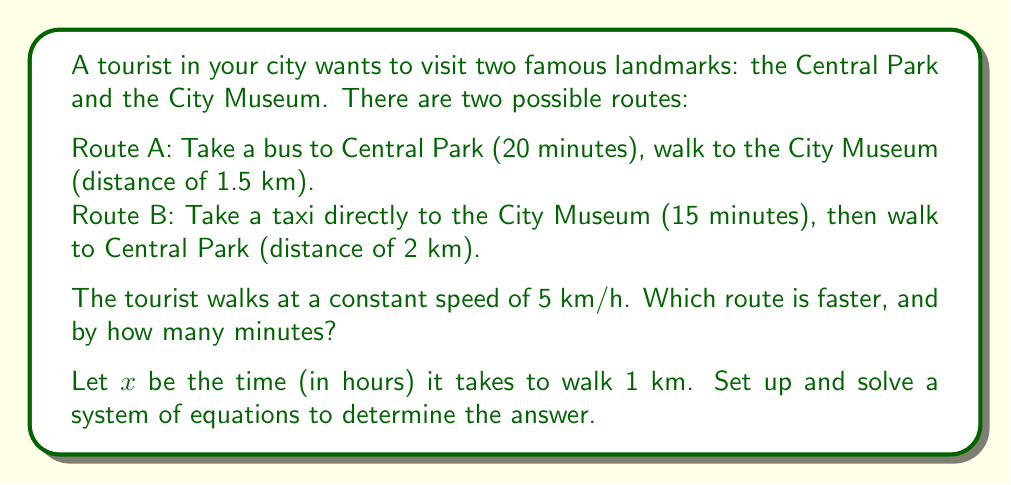Provide a solution to this math problem. Let's approach this step-by-step:

1) First, let's set up equations for the total time of each route:

   Route A: $\frac{20}{60} + 1.5x$ hours
   Route B: $\frac{15}{60} + 2x$ hours

2) We're told that the tourist walks at 5 km/h. This means:

   $\frac{1}{x} = 5$
   $x = \frac{1}{5} = 0.2$ hours per km

3) Now we can substitute this value into our route equations:

   Route A: $\frac{20}{60} + 1.5(0.2) = \frac{1}{3} + 0.3 = 0.633$ hours
   Route B: $\frac{15}{60} + 2(0.2) = 0.25 + 0.4 = 0.65$ hours

4) To convert the difference to minutes, we multiply by 60:

   $(0.65 - 0.633) * 60 = 0.017 * 60 = 1.02$ minutes

Therefore, Route A is faster by approximately 1 minute.
Answer: Route A is faster by 1 minute. 